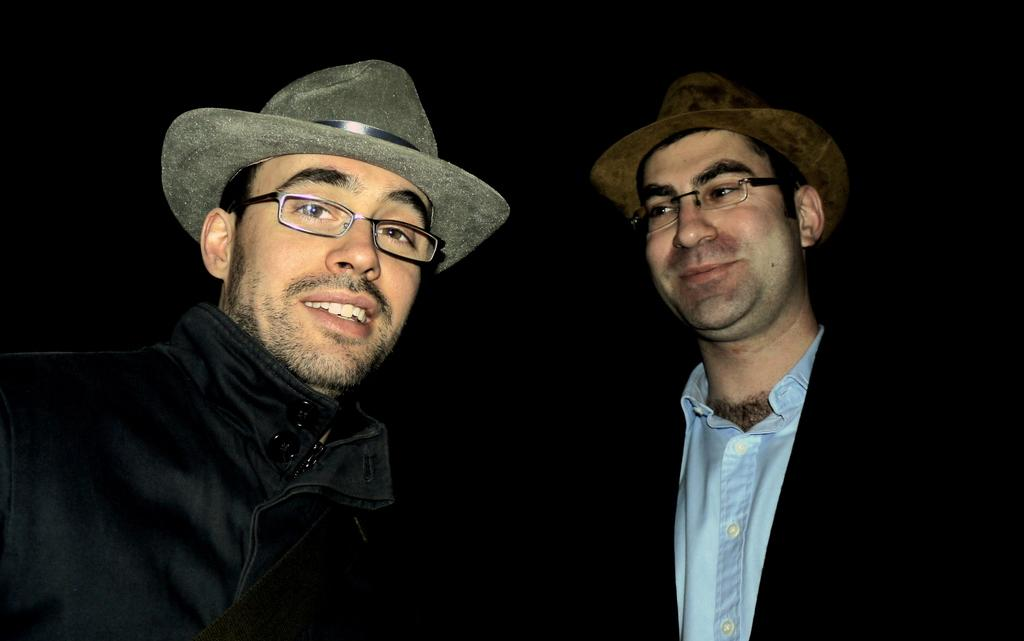What type of people are in the image? There are men in the image. What are the men wearing on their heads? The men are wearing hats. What type of eyewear are the men wearing? The men are wearing spectacles. What can be observed about the background of the image? The background of the image is dark. Can you tell me how many vans are parked behind the men in the image? There is no van present in the image; the background is dark. What type of lettuce is being used as a prop in the image? There is no lettuce present in the image. 